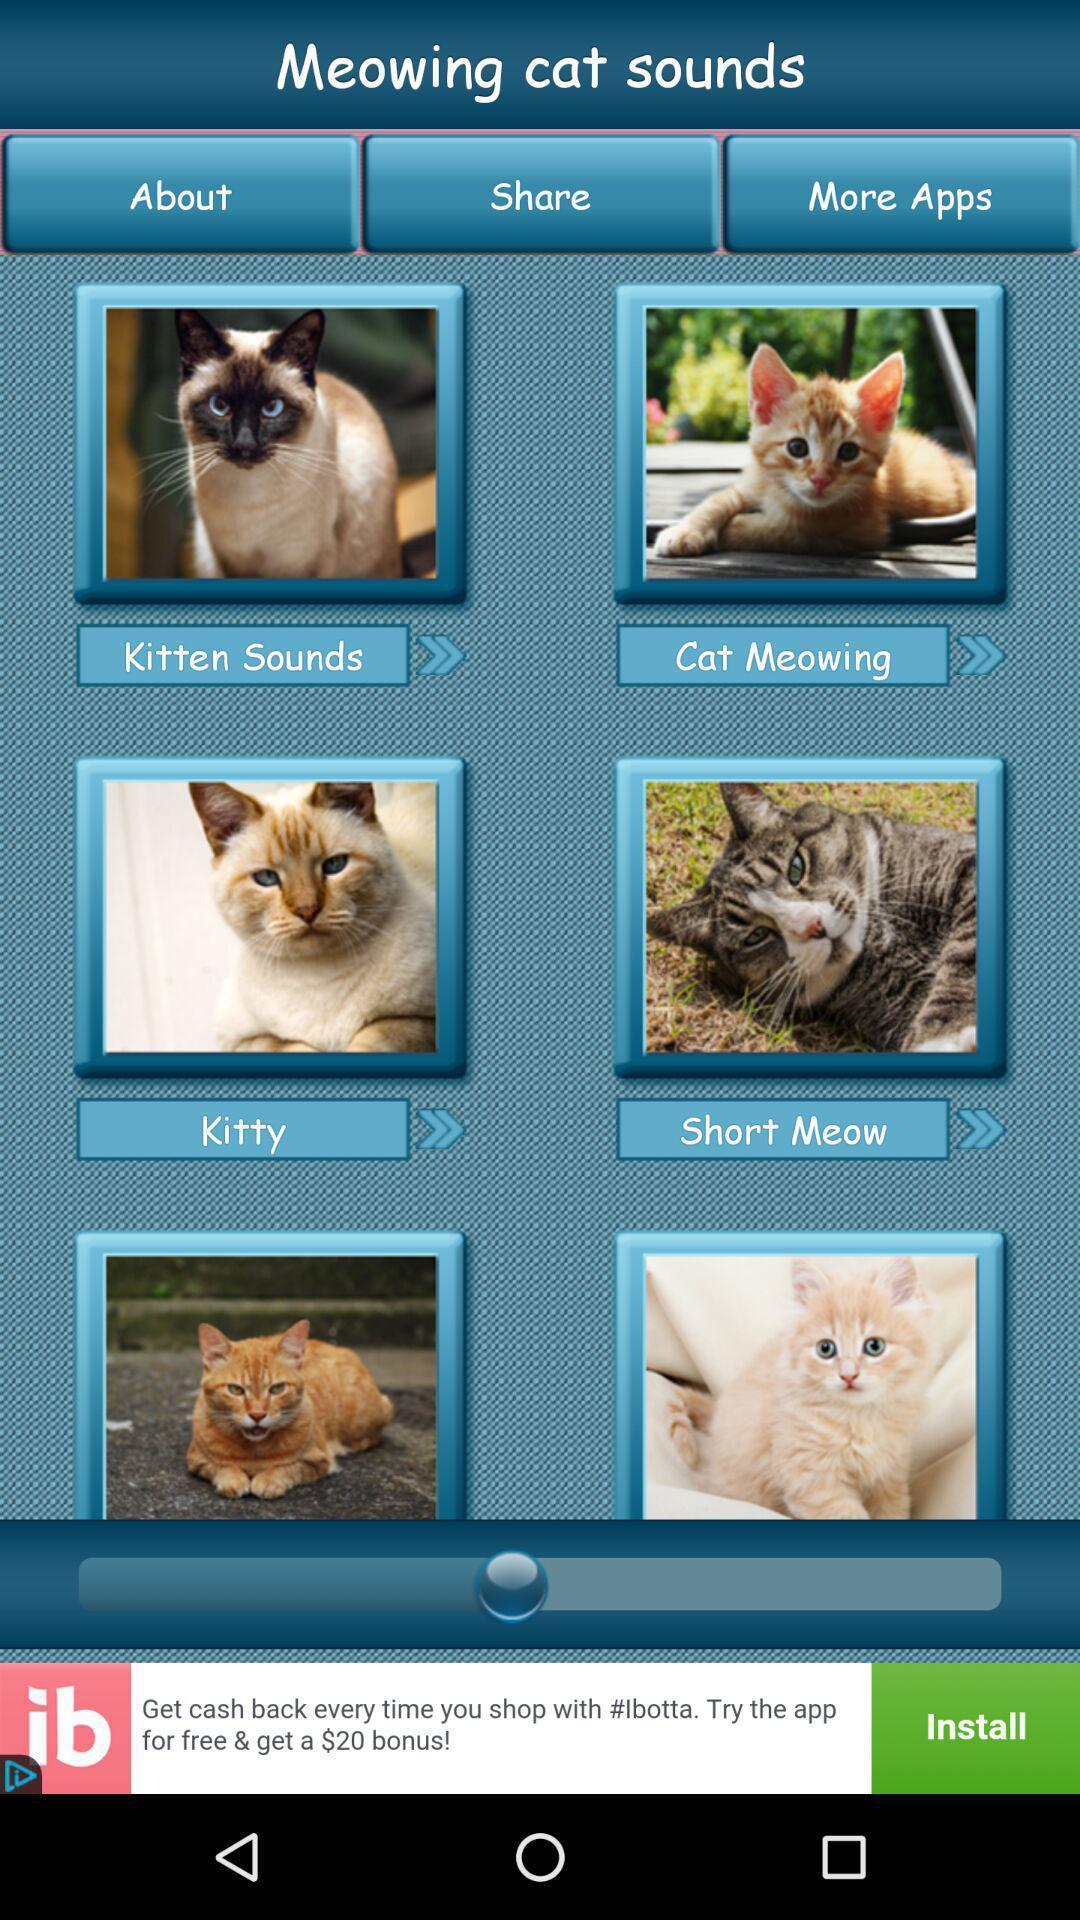Tell me what you see in this picture. Page of different cat sounds in the app. 